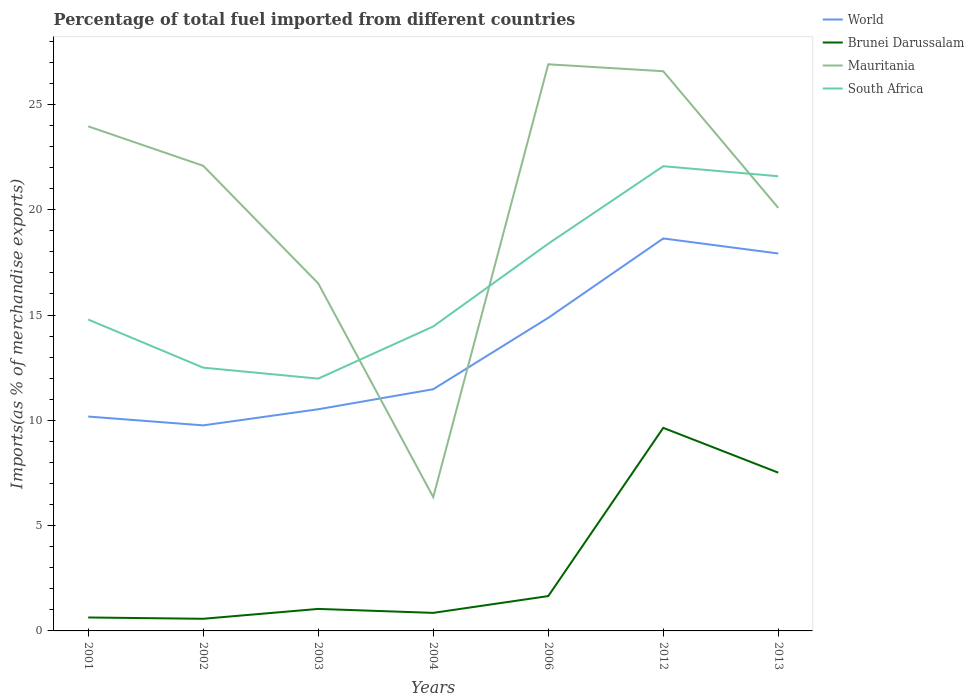Does the line corresponding to South Africa intersect with the line corresponding to Brunei Darussalam?
Your response must be concise. No. Is the number of lines equal to the number of legend labels?
Offer a terse response. Yes. Across all years, what is the maximum percentage of imports to different countries in South Africa?
Your answer should be very brief. 11.98. In which year was the percentage of imports to different countries in Brunei Darussalam maximum?
Offer a very short reply. 2002. What is the total percentage of imports to different countries in Brunei Darussalam in the graph?
Offer a terse response. -7.99. What is the difference between the highest and the second highest percentage of imports to different countries in World?
Give a very brief answer. 8.88. What is the difference between the highest and the lowest percentage of imports to different countries in Brunei Darussalam?
Provide a short and direct response. 2. Is the percentage of imports to different countries in World strictly greater than the percentage of imports to different countries in South Africa over the years?
Your answer should be compact. Yes. What is the difference between two consecutive major ticks on the Y-axis?
Keep it short and to the point. 5. Are the values on the major ticks of Y-axis written in scientific E-notation?
Provide a succinct answer. No. Does the graph contain any zero values?
Your response must be concise. No. Does the graph contain grids?
Provide a short and direct response. No. Where does the legend appear in the graph?
Make the answer very short. Top right. How are the legend labels stacked?
Offer a very short reply. Vertical. What is the title of the graph?
Make the answer very short. Percentage of total fuel imported from different countries. What is the label or title of the Y-axis?
Your answer should be compact. Imports(as % of merchandise exports). What is the Imports(as % of merchandise exports) of World in 2001?
Offer a very short reply. 10.18. What is the Imports(as % of merchandise exports) of Brunei Darussalam in 2001?
Your answer should be compact. 0.64. What is the Imports(as % of merchandise exports) of Mauritania in 2001?
Provide a short and direct response. 23.96. What is the Imports(as % of merchandise exports) in South Africa in 2001?
Your answer should be very brief. 14.79. What is the Imports(as % of merchandise exports) of World in 2002?
Your answer should be very brief. 9.76. What is the Imports(as % of merchandise exports) in Brunei Darussalam in 2002?
Make the answer very short. 0.58. What is the Imports(as % of merchandise exports) in Mauritania in 2002?
Your answer should be compact. 22.09. What is the Imports(as % of merchandise exports) in South Africa in 2002?
Your answer should be compact. 12.5. What is the Imports(as % of merchandise exports) in World in 2003?
Give a very brief answer. 10.53. What is the Imports(as % of merchandise exports) of Brunei Darussalam in 2003?
Your answer should be compact. 1.05. What is the Imports(as % of merchandise exports) in Mauritania in 2003?
Offer a terse response. 16.5. What is the Imports(as % of merchandise exports) in South Africa in 2003?
Give a very brief answer. 11.98. What is the Imports(as % of merchandise exports) of World in 2004?
Keep it short and to the point. 11.48. What is the Imports(as % of merchandise exports) in Brunei Darussalam in 2004?
Make the answer very short. 0.86. What is the Imports(as % of merchandise exports) of Mauritania in 2004?
Your answer should be very brief. 6.35. What is the Imports(as % of merchandise exports) in South Africa in 2004?
Offer a very short reply. 14.46. What is the Imports(as % of merchandise exports) of World in 2006?
Offer a terse response. 14.87. What is the Imports(as % of merchandise exports) in Brunei Darussalam in 2006?
Offer a terse response. 1.65. What is the Imports(as % of merchandise exports) in Mauritania in 2006?
Your response must be concise. 26.91. What is the Imports(as % of merchandise exports) in South Africa in 2006?
Your answer should be compact. 18.39. What is the Imports(as % of merchandise exports) in World in 2012?
Give a very brief answer. 18.64. What is the Imports(as % of merchandise exports) in Brunei Darussalam in 2012?
Ensure brevity in your answer.  9.64. What is the Imports(as % of merchandise exports) of Mauritania in 2012?
Make the answer very short. 26.58. What is the Imports(as % of merchandise exports) in South Africa in 2012?
Offer a very short reply. 22.07. What is the Imports(as % of merchandise exports) in World in 2013?
Your answer should be compact. 17.92. What is the Imports(as % of merchandise exports) in Brunei Darussalam in 2013?
Your answer should be compact. 7.52. What is the Imports(as % of merchandise exports) in Mauritania in 2013?
Offer a terse response. 20.09. What is the Imports(as % of merchandise exports) of South Africa in 2013?
Your response must be concise. 21.59. Across all years, what is the maximum Imports(as % of merchandise exports) in World?
Provide a succinct answer. 18.64. Across all years, what is the maximum Imports(as % of merchandise exports) in Brunei Darussalam?
Ensure brevity in your answer.  9.64. Across all years, what is the maximum Imports(as % of merchandise exports) of Mauritania?
Your answer should be compact. 26.91. Across all years, what is the maximum Imports(as % of merchandise exports) of South Africa?
Your answer should be compact. 22.07. Across all years, what is the minimum Imports(as % of merchandise exports) of World?
Your answer should be very brief. 9.76. Across all years, what is the minimum Imports(as % of merchandise exports) of Brunei Darussalam?
Offer a terse response. 0.58. Across all years, what is the minimum Imports(as % of merchandise exports) in Mauritania?
Ensure brevity in your answer.  6.35. Across all years, what is the minimum Imports(as % of merchandise exports) in South Africa?
Offer a terse response. 11.98. What is the total Imports(as % of merchandise exports) of World in the graph?
Give a very brief answer. 93.37. What is the total Imports(as % of merchandise exports) of Brunei Darussalam in the graph?
Ensure brevity in your answer.  21.93. What is the total Imports(as % of merchandise exports) in Mauritania in the graph?
Provide a succinct answer. 142.47. What is the total Imports(as % of merchandise exports) of South Africa in the graph?
Offer a terse response. 115.77. What is the difference between the Imports(as % of merchandise exports) of World in 2001 and that in 2002?
Ensure brevity in your answer.  0.42. What is the difference between the Imports(as % of merchandise exports) of Brunei Darussalam in 2001 and that in 2002?
Your answer should be very brief. 0.06. What is the difference between the Imports(as % of merchandise exports) of Mauritania in 2001 and that in 2002?
Your response must be concise. 1.87. What is the difference between the Imports(as % of merchandise exports) of South Africa in 2001 and that in 2002?
Provide a short and direct response. 2.29. What is the difference between the Imports(as % of merchandise exports) in World in 2001 and that in 2003?
Provide a succinct answer. -0.35. What is the difference between the Imports(as % of merchandise exports) in Brunei Darussalam in 2001 and that in 2003?
Your answer should be compact. -0.41. What is the difference between the Imports(as % of merchandise exports) in Mauritania in 2001 and that in 2003?
Your answer should be very brief. 7.46. What is the difference between the Imports(as % of merchandise exports) in South Africa in 2001 and that in 2003?
Your answer should be very brief. 2.81. What is the difference between the Imports(as % of merchandise exports) of World in 2001 and that in 2004?
Provide a succinct answer. -1.3. What is the difference between the Imports(as % of merchandise exports) of Brunei Darussalam in 2001 and that in 2004?
Keep it short and to the point. -0.22. What is the difference between the Imports(as % of merchandise exports) of Mauritania in 2001 and that in 2004?
Your answer should be compact. 17.61. What is the difference between the Imports(as % of merchandise exports) of South Africa in 2001 and that in 2004?
Your response must be concise. 0.33. What is the difference between the Imports(as % of merchandise exports) of World in 2001 and that in 2006?
Provide a succinct answer. -4.69. What is the difference between the Imports(as % of merchandise exports) of Brunei Darussalam in 2001 and that in 2006?
Provide a short and direct response. -1.02. What is the difference between the Imports(as % of merchandise exports) in Mauritania in 2001 and that in 2006?
Your response must be concise. -2.95. What is the difference between the Imports(as % of merchandise exports) of South Africa in 2001 and that in 2006?
Provide a short and direct response. -3.6. What is the difference between the Imports(as % of merchandise exports) of World in 2001 and that in 2012?
Make the answer very short. -8.46. What is the difference between the Imports(as % of merchandise exports) in Brunei Darussalam in 2001 and that in 2012?
Keep it short and to the point. -9. What is the difference between the Imports(as % of merchandise exports) in Mauritania in 2001 and that in 2012?
Your answer should be very brief. -2.62. What is the difference between the Imports(as % of merchandise exports) of South Africa in 2001 and that in 2012?
Give a very brief answer. -7.28. What is the difference between the Imports(as % of merchandise exports) in World in 2001 and that in 2013?
Ensure brevity in your answer.  -7.74. What is the difference between the Imports(as % of merchandise exports) in Brunei Darussalam in 2001 and that in 2013?
Provide a short and direct response. -6.88. What is the difference between the Imports(as % of merchandise exports) of Mauritania in 2001 and that in 2013?
Provide a succinct answer. 3.87. What is the difference between the Imports(as % of merchandise exports) of South Africa in 2001 and that in 2013?
Keep it short and to the point. -6.8. What is the difference between the Imports(as % of merchandise exports) in World in 2002 and that in 2003?
Make the answer very short. -0.77. What is the difference between the Imports(as % of merchandise exports) in Brunei Darussalam in 2002 and that in 2003?
Keep it short and to the point. -0.47. What is the difference between the Imports(as % of merchandise exports) in Mauritania in 2002 and that in 2003?
Your answer should be very brief. 5.59. What is the difference between the Imports(as % of merchandise exports) of South Africa in 2002 and that in 2003?
Offer a terse response. 0.52. What is the difference between the Imports(as % of merchandise exports) of World in 2002 and that in 2004?
Your answer should be very brief. -1.72. What is the difference between the Imports(as % of merchandise exports) in Brunei Darussalam in 2002 and that in 2004?
Provide a succinct answer. -0.28. What is the difference between the Imports(as % of merchandise exports) of Mauritania in 2002 and that in 2004?
Offer a very short reply. 15.73. What is the difference between the Imports(as % of merchandise exports) of South Africa in 2002 and that in 2004?
Make the answer very short. -1.96. What is the difference between the Imports(as % of merchandise exports) of World in 2002 and that in 2006?
Provide a short and direct response. -5.11. What is the difference between the Imports(as % of merchandise exports) in Brunei Darussalam in 2002 and that in 2006?
Offer a terse response. -1.08. What is the difference between the Imports(as % of merchandise exports) in Mauritania in 2002 and that in 2006?
Ensure brevity in your answer.  -4.82. What is the difference between the Imports(as % of merchandise exports) of South Africa in 2002 and that in 2006?
Keep it short and to the point. -5.89. What is the difference between the Imports(as % of merchandise exports) in World in 2002 and that in 2012?
Offer a very short reply. -8.88. What is the difference between the Imports(as % of merchandise exports) of Brunei Darussalam in 2002 and that in 2012?
Offer a very short reply. -9.07. What is the difference between the Imports(as % of merchandise exports) of Mauritania in 2002 and that in 2012?
Ensure brevity in your answer.  -4.49. What is the difference between the Imports(as % of merchandise exports) in South Africa in 2002 and that in 2012?
Keep it short and to the point. -9.57. What is the difference between the Imports(as % of merchandise exports) of World in 2002 and that in 2013?
Give a very brief answer. -8.16. What is the difference between the Imports(as % of merchandise exports) of Brunei Darussalam in 2002 and that in 2013?
Offer a terse response. -6.94. What is the difference between the Imports(as % of merchandise exports) of Mauritania in 2002 and that in 2013?
Provide a succinct answer. 2. What is the difference between the Imports(as % of merchandise exports) of South Africa in 2002 and that in 2013?
Your response must be concise. -9.09. What is the difference between the Imports(as % of merchandise exports) in World in 2003 and that in 2004?
Your answer should be compact. -0.95. What is the difference between the Imports(as % of merchandise exports) in Brunei Darussalam in 2003 and that in 2004?
Your response must be concise. 0.19. What is the difference between the Imports(as % of merchandise exports) in Mauritania in 2003 and that in 2004?
Offer a very short reply. 10.15. What is the difference between the Imports(as % of merchandise exports) in South Africa in 2003 and that in 2004?
Make the answer very short. -2.48. What is the difference between the Imports(as % of merchandise exports) in World in 2003 and that in 2006?
Offer a very short reply. -4.34. What is the difference between the Imports(as % of merchandise exports) in Brunei Darussalam in 2003 and that in 2006?
Provide a succinct answer. -0.61. What is the difference between the Imports(as % of merchandise exports) of Mauritania in 2003 and that in 2006?
Give a very brief answer. -10.41. What is the difference between the Imports(as % of merchandise exports) of South Africa in 2003 and that in 2006?
Your answer should be compact. -6.41. What is the difference between the Imports(as % of merchandise exports) of World in 2003 and that in 2012?
Provide a short and direct response. -8.11. What is the difference between the Imports(as % of merchandise exports) in Brunei Darussalam in 2003 and that in 2012?
Provide a short and direct response. -8.6. What is the difference between the Imports(as % of merchandise exports) in Mauritania in 2003 and that in 2012?
Provide a short and direct response. -10.08. What is the difference between the Imports(as % of merchandise exports) of South Africa in 2003 and that in 2012?
Provide a short and direct response. -10.09. What is the difference between the Imports(as % of merchandise exports) of World in 2003 and that in 2013?
Ensure brevity in your answer.  -7.4. What is the difference between the Imports(as % of merchandise exports) in Brunei Darussalam in 2003 and that in 2013?
Provide a succinct answer. -6.47. What is the difference between the Imports(as % of merchandise exports) of Mauritania in 2003 and that in 2013?
Your response must be concise. -3.59. What is the difference between the Imports(as % of merchandise exports) of South Africa in 2003 and that in 2013?
Make the answer very short. -9.61. What is the difference between the Imports(as % of merchandise exports) in World in 2004 and that in 2006?
Offer a very short reply. -3.39. What is the difference between the Imports(as % of merchandise exports) in Brunei Darussalam in 2004 and that in 2006?
Your answer should be very brief. -0.8. What is the difference between the Imports(as % of merchandise exports) in Mauritania in 2004 and that in 2006?
Provide a short and direct response. -20.55. What is the difference between the Imports(as % of merchandise exports) in South Africa in 2004 and that in 2006?
Provide a succinct answer. -3.93. What is the difference between the Imports(as % of merchandise exports) in World in 2004 and that in 2012?
Make the answer very short. -7.16. What is the difference between the Imports(as % of merchandise exports) of Brunei Darussalam in 2004 and that in 2012?
Your response must be concise. -8.79. What is the difference between the Imports(as % of merchandise exports) of Mauritania in 2004 and that in 2012?
Your answer should be compact. -20.22. What is the difference between the Imports(as % of merchandise exports) of South Africa in 2004 and that in 2012?
Provide a short and direct response. -7.61. What is the difference between the Imports(as % of merchandise exports) in World in 2004 and that in 2013?
Your answer should be compact. -6.44. What is the difference between the Imports(as % of merchandise exports) in Brunei Darussalam in 2004 and that in 2013?
Provide a short and direct response. -6.66. What is the difference between the Imports(as % of merchandise exports) of Mauritania in 2004 and that in 2013?
Provide a short and direct response. -13.73. What is the difference between the Imports(as % of merchandise exports) in South Africa in 2004 and that in 2013?
Your answer should be very brief. -7.13. What is the difference between the Imports(as % of merchandise exports) of World in 2006 and that in 2012?
Your response must be concise. -3.77. What is the difference between the Imports(as % of merchandise exports) in Brunei Darussalam in 2006 and that in 2012?
Make the answer very short. -7.99. What is the difference between the Imports(as % of merchandise exports) in Mauritania in 2006 and that in 2012?
Ensure brevity in your answer.  0.33. What is the difference between the Imports(as % of merchandise exports) in South Africa in 2006 and that in 2012?
Your answer should be compact. -3.68. What is the difference between the Imports(as % of merchandise exports) of World in 2006 and that in 2013?
Provide a succinct answer. -3.05. What is the difference between the Imports(as % of merchandise exports) in Brunei Darussalam in 2006 and that in 2013?
Your response must be concise. -5.86. What is the difference between the Imports(as % of merchandise exports) of Mauritania in 2006 and that in 2013?
Make the answer very short. 6.82. What is the difference between the Imports(as % of merchandise exports) in South Africa in 2006 and that in 2013?
Keep it short and to the point. -3.2. What is the difference between the Imports(as % of merchandise exports) in World in 2012 and that in 2013?
Offer a very short reply. 0.71. What is the difference between the Imports(as % of merchandise exports) of Brunei Darussalam in 2012 and that in 2013?
Keep it short and to the point. 2.13. What is the difference between the Imports(as % of merchandise exports) of Mauritania in 2012 and that in 2013?
Ensure brevity in your answer.  6.49. What is the difference between the Imports(as % of merchandise exports) in South Africa in 2012 and that in 2013?
Your answer should be compact. 0.48. What is the difference between the Imports(as % of merchandise exports) in World in 2001 and the Imports(as % of merchandise exports) in Brunei Darussalam in 2002?
Keep it short and to the point. 9.6. What is the difference between the Imports(as % of merchandise exports) of World in 2001 and the Imports(as % of merchandise exports) of Mauritania in 2002?
Your answer should be compact. -11.91. What is the difference between the Imports(as % of merchandise exports) of World in 2001 and the Imports(as % of merchandise exports) of South Africa in 2002?
Your answer should be compact. -2.32. What is the difference between the Imports(as % of merchandise exports) of Brunei Darussalam in 2001 and the Imports(as % of merchandise exports) of Mauritania in 2002?
Make the answer very short. -21.45. What is the difference between the Imports(as % of merchandise exports) of Brunei Darussalam in 2001 and the Imports(as % of merchandise exports) of South Africa in 2002?
Your response must be concise. -11.86. What is the difference between the Imports(as % of merchandise exports) of Mauritania in 2001 and the Imports(as % of merchandise exports) of South Africa in 2002?
Your response must be concise. 11.46. What is the difference between the Imports(as % of merchandise exports) in World in 2001 and the Imports(as % of merchandise exports) in Brunei Darussalam in 2003?
Provide a short and direct response. 9.13. What is the difference between the Imports(as % of merchandise exports) in World in 2001 and the Imports(as % of merchandise exports) in Mauritania in 2003?
Make the answer very short. -6.32. What is the difference between the Imports(as % of merchandise exports) of World in 2001 and the Imports(as % of merchandise exports) of South Africa in 2003?
Offer a very short reply. -1.8. What is the difference between the Imports(as % of merchandise exports) of Brunei Darussalam in 2001 and the Imports(as % of merchandise exports) of Mauritania in 2003?
Ensure brevity in your answer.  -15.86. What is the difference between the Imports(as % of merchandise exports) of Brunei Darussalam in 2001 and the Imports(as % of merchandise exports) of South Africa in 2003?
Offer a very short reply. -11.34. What is the difference between the Imports(as % of merchandise exports) of Mauritania in 2001 and the Imports(as % of merchandise exports) of South Africa in 2003?
Offer a terse response. 11.98. What is the difference between the Imports(as % of merchandise exports) of World in 2001 and the Imports(as % of merchandise exports) of Brunei Darussalam in 2004?
Offer a terse response. 9.32. What is the difference between the Imports(as % of merchandise exports) of World in 2001 and the Imports(as % of merchandise exports) of Mauritania in 2004?
Offer a terse response. 3.83. What is the difference between the Imports(as % of merchandise exports) of World in 2001 and the Imports(as % of merchandise exports) of South Africa in 2004?
Your answer should be compact. -4.28. What is the difference between the Imports(as % of merchandise exports) in Brunei Darussalam in 2001 and the Imports(as % of merchandise exports) in Mauritania in 2004?
Your answer should be compact. -5.72. What is the difference between the Imports(as % of merchandise exports) of Brunei Darussalam in 2001 and the Imports(as % of merchandise exports) of South Africa in 2004?
Ensure brevity in your answer.  -13.82. What is the difference between the Imports(as % of merchandise exports) in Mauritania in 2001 and the Imports(as % of merchandise exports) in South Africa in 2004?
Give a very brief answer. 9.5. What is the difference between the Imports(as % of merchandise exports) of World in 2001 and the Imports(as % of merchandise exports) of Brunei Darussalam in 2006?
Give a very brief answer. 8.53. What is the difference between the Imports(as % of merchandise exports) of World in 2001 and the Imports(as % of merchandise exports) of Mauritania in 2006?
Ensure brevity in your answer.  -16.73. What is the difference between the Imports(as % of merchandise exports) in World in 2001 and the Imports(as % of merchandise exports) in South Africa in 2006?
Your answer should be compact. -8.21. What is the difference between the Imports(as % of merchandise exports) in Brunei Darussalam in 2001 and the Imports(as % of merchandise exports) in Mauritania in 2006?
Offer a terse response. -26.27. What is the difference between the Imports(as % of merchandise exports) in Brunei Darussalam in 2001 and the Imports(as % of merchandise exports) in South Africa in 2006?
Make the answer very short. -17.75. What is the difference between the Imports(as % of merchandise exports) of Mauritania in 2001 and the Imports(as % of merchandise exports) of South Africa in 2006?
Provide a succinct answer. 5.57. What is the difference between the Imports(as % of merchandise exports) in World in 2001 and the Imports(as % of merchandise exports) in Brunei Darussalam in 2012?
Provide a short and direct response. 0.54. What is the difference between the Imports(as % of merchandise exports) in World in 2001 and the Imports(as % of merchandise exports) in Mauritania in 2012?
Provide a short and direct response. -16.4. What is the difference between the Imports(as % of merchandise exports) of World in 2001 and the Imports(as % of merchandise exports) of South Africa in 2012?
Offer a very short reply. -11.89. What is the difference between the Imports(as % of merchandise exports) in Brunei Darussalam in 2001 and the Imports(as % of merchandise exports) in Mauritania in 2012?
Offer a very short reply. -25.94. What is the difference between the Imports(as % of merchandise exports) of Brunei Darussalam in 2001 and the Imports(as % of merchandise exports) of South Africa in 2012?
Ensure brevity in your answer.  -21.43. What is the difference between the Imports(as % of merchandise exports) of Mauritania in 2001 and the Imports(as % of merchandise exports) of South Africa in 2012?
Keep it short and to the point. 1.89. What is the difference between the Imports(as % of merchandise exports) in World in 2001 and the Imports(as % of merchandise exports) in Brunei Darussalam in 2013?
Offer a very short reply. 2.66. What is the difference between the Imports(as % of merchandise exports) of World in 2001 and the Imports(as % of merchandise exports) of Mauritania in 2013?
Offer a terse response. -9.91. What is the difference between the Imports(as % of merchandise exports) in World in 2001 and the Imports(as % of merchandise exports) in South Africa in 2013?
Offer a very short reply. -11.41. What is the difference between the Imports(as % of merchandise exports) of Brunei Darussalam in 2001 and the Imports(as % of merchandise exports) of Mauritania in 2013?
Make the answer very short. -19.45. What is the difference between the Imports(as % of merchandise exports) of Brunei Darussalam in 2001 and the Imports(as % of merchandise exports) of South Africa in 2013?
Your answer should be very brief. -20.95. What is the difference between the Imports(as % of merchandise exports) in Mauritania in 2001 and the Imports(as % of merchandise exports) in South Africa in 2013?
Provide a short and direct response. 2.37. What is the difference between the Imports(as % of merchandise exports) of World in 2002 and the Imports(as % of merchandise exports) of Brunei Darussalam in 2003?
Your response must be concise. 8.72. What is the difference between the Imports(as % of merchandise exports) in World in 2002 and the Imports(as % of merchandise exports) in Mauritania in 2003?
Your answer should be very brief. -6.74. What is the difference between the Imports(as % of merchandise exports) of World in 2002 and the Imports(as % of merchandise exports) of South Africa in 2003?
Your response must be concise. -2.22. What is the difference between the Imports(as % of merchandise exports) in Brunei Darussalam in 2002 and the Imports(as % of merchandise exports) in Mauritania in 2003?
Your answer should be compact. -15.92. What is the difference between the Imports(as % of merchandise exports) in Brunei Darussalam in 2002 and the Imports(as % of merchandise exports) in South Africa in 2003?
Your answer should be compact. -11.4. What is the difference between the Imports(as % of merchandise exports) in Mauritania in 2002 and the Imports(as % of merchandise exports) in South Africa in 2003?
Provide a succinct answer. 10.11. What is the difference between the Imports(as % of merchandise exports) of World in 2002 and the Imports(as % of merchandise exports) of Brunei Darussalam in 2004?
Your answer should be very brief. 8.9. What is the difference between the Imports(as % of merchandise exports) in World in 2002 and the Imports(as % of merchandise exports) in Mauritania in 2004?
Ensure brevity in your answer.  3.41. What is the difference between the Imports(as % of merchandise exports) in World in 2002 and the Imports(as % of merchandise exports) in South Africa in 2004?
Ensure brevity in your answer.  -4.7. What is the difference between the Imports(as % of merchandise exports) of Brunei Darussalam in 2002 and the Imports(as % of merchandise exports) of Mauritania in 2004?
Offer a very short reply. -5.78. What is the difference between the Imports(as % of merchandise exports) in Brunei Darussalam in 2002 and the Imports(as % of merchandise exports) in South Africa in 2004?
Provide a short and direct response. -13.88. What is the difference between the Imports(as % of merchandise exports) in Mauritania in 2002 and the Imports(as % of merchandise exports) in South Africa in 2004?
Your answer should be very brief. 7.63. What is the difference between the Imports(as % of merchandise exports) of World in 2002 and the Imports(as % of merchandise exports) of Brunei Darussalam in 2006?
Provide a short and direct response. 8.11. What is the difference between the Imports(as % of merchandise exports) in World in 2002 and the Imports(as % of merchandise exports) in Mauritania in 2006?
Provide a short and direct response. -17.15. What is the difference between the Imports(as % of merchandise exports) in World in 2002 and the Imports(as % of merchandise exports) in South Africa in 2006?
Keep it short and to the point. -8.63. What is the difference between the Imports(as % of merchandise exports) of Brunei Darussalam in 2002 and the Imports(as % of merchandise exports) of Mauritania in 2006?
Offer a terse response. -26.33. What is the difference between the Imports(as % of merchandise exports) in Brunei Darussalam in 2002 and the Imports(as % of merchandise exports) in South Africa in 2006?
Provide a succinct answer. -17.81. What is the difference between the Imports(as % of merchandise exports) in Mauritania in 2002 and the Imports(as % of merchandise exports) in South Africa in 2006?
Offer a very short reply. 3.7. What is the difference between the Imports(as % of merchandise exports) in World in 2002 and the Imports(as % of merchandise exports) in Brunei Darussalam in 2012?
Offer a very short reply. 0.12. What is the difference between the Imports(as % of merchandise exports) in World in 2002 and the Imports(as % of merchandise exports) in Mauritania in 2012?
Provide a succinct answer. -16.82. What is the difference between the Imports(as % of merchandise exports) of World in 2002 and the Imports(as % of merchandise exports) of South Africa in 2012?
Offer a terse response. -12.31. What is the difference between the Imports(as % of merchandise exports) in Brunei Darussalam in 2002 and the Imports(as % of merchandise exports) in Mauritania in 2012?
Offer a very short reply. -26. What is the difference between the Imports(as % of merchandise exports) of Brunei Darussalam in 2002 and the Imports(as % of merchandise exports) of South Africa in 2012?
Your answer should be compact. -21.49. What is the difference between the Imports(as % of merchandise exports) in Mauritania in 2002 and the Imports(as % of merchandise exports) in South Africa in 2012?
Provide a succinct answer. 0.02. What is the difference between the Imports(as % of merchandise exports) of World in 2002 and the Imports(as % of merchandise exports) of Brunei Darussalam in 2013?
Your answer should be compact. 2.25. What is the difference between the Imports(as % of merchandise exports) of World in 2002 and the Imports(as % of merchandise exports) of Mauritania in 2013?
Make the answer very short. -10.33. What is the difference between the Imports(as % of merchandise exports) in World in 2002 and the Imports(as % of merchandise exports) in South Africa in 2013?
Make the answer very short. -11.83. What is the difference between the Imports(as % of merchandise exports) in Brunei Darussalam in 2002 and the Imports(as % of merchandise exports) in Mauritania in 2013?
Make the answer very short. -19.51. What is the difference between the Imports(as % of merchandise exports) of Brunei Darussalam in 2002 and the Imports(as % of merchandise exports) of South Africa in 2013?
Provide a short and direct response. -21.01. What is the difference between the Imports(as % of merchandise exports) in Mauritania in 2002 and the Imports(as % of merchandise exports) in South Africa in 2013?
Keep it short and to the point. 0.5. What is the difference between the Imports(as % of merchandise exports) of World in 2003 and the Imports(as % of merchandise exports) of Brunei Darussalam in 2004?
Your answer should be compact. 9.67. What is the difference between the Imports(as % of merchandise exports) in World in 2003 and the Imports(as % of merchandise exports) in Mauritania in 2004?
Your answer should be compact. 4.17. What is the difference between the Imports(as % of merchandise exports) of World in 2003 and the Imports(as % of merchandise exports) of South Africa in 2004?
Keep it short and to the point. -3.93. What is the difference between the Imports(as % of merchandise exports) in Brunei Darussalam in 2003 and the Imports(as % of merchandise exports) in Mauritania in 2004?
Your response must be concise. -5.31. What is the difference between the Imports(as % of merchandise exports) in Brunei Darussalam in 2003 and the Imports(as % of merchandise exports) in South Africa in 2004?
Ensure brevity in your answer.  -13.41. What is the difference between the Imports(as % of merchandise exports) of Mauritania in 2003 and the Imports(as % of merchandise exports) of South Africa in 2004?
Offer a terse response. 2.04. What is the difference between the Imports(as % of merchandise exports) of World in 2003 and the Imports(as % of merchandise exports) of Brunei Darussalam in 2006?
Offer a terse response. 8.87. What is the difference between the Imports(as % of merchandise exports) in World in 2003 and the Imports(as % of merchandise exports) in Mauritania in 2006?
Make the answer very short. -16.38. What is the difference between the Imports(as % of merchandise exports) in World in 2003 and the Imports(as % of merchandise exports) in South Africa in 2006?
Provide a short and direct response. -7.86. What is the difference between the Imports(as % of merchandise exports) of Brunei Darussalam in 2003 and the Imports(as % of merchandise exports) of Mauritania in 2006?
Give a very brief answer. -25.86. What is the difference between the Imports(as % of merchandise exports) in Brunei Darussalam in 2003 and the Imports(as % of merchandise exports) in South Africa in 2006?
Give a very brief answer. -17.34. What is the difference between the Imports(as % of merchandise exports) of Mauritania in 2003 and the Imports(as % of merchandise exports) of South Africa in 2006?
Your response must be concise. -1.89. What is the difference between the Imports(as % of merchandise exports) of World in 2003 and the Imports(as % of merchandise exports) of Brunei Darussalam in 2012?
Provide a succinct answer. 0.88. What is the difference between the Imports(as % of merchandise exports) in World in 2003 and the Imports(as % of merchandise exports) in Mauritania in 2012?
Offer a terse response. -16.05. What is the difference between the Imports(as % of merchandise exports) of World in 2003 and the Imports(as % of merchandise exports) of South Africa in 2012?
Provide a short and direct response. -11.54. What is the difference between the Imports(as % of merchandise exports) of Brunei Darussalam in 2003 and the Imports(as % of merchandise exports) of Mauritania in 2012?
Your response must be concise. -25.53. What is the difference between the Imports(as % of merchandise exports) in Brunei Darussalam in 2003 and the Imports(as % of merchandise exports) in South Africa in 2012?
Keep it short and to the point. -21.02. What is the difference between the Imports(as % of merchandise exports) of Mauritania in 2003 and the Imports(as % of merchandise exports) of South Africa in 2012?
Offer a very short reply. -5.57. What is the difference between the Imports(as % of merchandise exports) of World in 2003 and the Imports(as % of merchandise exports) of Brunei Darussalam in 2013?
Offer a very short reply. 3.01. What is the difference between the Imports(as % of merchandise exports) of World in 2003 and the Imports(as % of merchandise exports) of Mauritania in 2013?
Provide a short and direct response. -9.56. What is the difference between the Imports(as % of merchandise exports) of World in 2003 and the Imports(as % of merchandise exports) of South Africa in 2013?
Give a very brief answer. -11.06. What is the difference between the Imports(as % of merchandise exports) in Brunei Darussalam in 2003 and the Imports(as % of merchandise exports) in Mauritania in 2013?
Keep it short and to the point. -19.04. What is the difference between the Imports(as % of merchandise exports) in Brunei Darussalam in 2003 and the Imports(as % of merchandise exports) in South Africa in 2013?
Your answer should be compact. -20.55. What is the difference between the Imports(as % of merchandise exports) of Mauritania in 2003 and the Imports(as % of merchandise exports) of South Africa in 2013?
Provide a short and direct response. -5.09. What is the difference between the Imports(as % of merchandise exports) in World in 2004 and the Imports(as % of merchandise exports) in Brunei Darussalam in 2006?
Make the answer very short. 9.82. What is the difference between the Imports(as % of merchandise exports) of World in 2004 and the Imports(as % of merchandise exports) of Mauritania in 2006?
Give a very brief answer. -15.43. What is the difference between the Imports(as % of merchandise exports) in World in 2004 and the Imports(as % of merchandise exports) in South Africa in 2006?
Make the answer very short. -6.91. What is the difference between the Imports(as % of merchandise exports) of Brunei Darussalam in 2004 and the Imports(as % of merchandise exports) of Mauritania in 2006?
Give a very brief answer. -26.05. What is the difference between the Imports(as % of merchandise exports) of Brunei Darussalam in 2004 and the Imports(as % of merchandise exports) of South Africa in 2006?
Make the answer very short. -17.53. What is the difference between the Imports(as % of merchandise exports) of Mauritania in 2004 and the Imports(as % of merchandise exports) of South Africa in 2006?
Offer a terse response. -12.03. What is the difference between the Imports(as % of merchandise exports) in World in 2004 and the Imports(as % of merchandise exports) in Brunei Darussalam in 2012?
Your answer should be compact. 1.83. What is the difference between the Imports(as % of merchandise exports) in World in 2004 and the Imports(as % of merchandise exports) in Mauritania in 2012?
Keep it short and to the point. -15.1. What is the difference between the Imports(as % of merchandise exports) of World in 2004 and the Imports(as % of merchandise exports) of South Africa in 2012?
Ensure brevity in your answer.  -10.59. What is the difference between the Imports(as % of merchandise exports) in Brunei Darussalam in 2004 and the Imports(as % of merchandise exports) in Mauritania in 2012?
Give a very brief answer. -25.72. What is the difference between the Imports(as % of merchandise exports) of Brunei Darussalam in 2004 and the Imports(as % of merchandise exports) of South Africa in 2012?
Make the answer very short. -21.21. What is the difference between the Imports(as % of merchandise exports) of Mauritania in 2004 and the Imports(as % of merchandise exports) of South Africa in 2012?
Your answer should be compact. -15.71. What is the difference between the Imports(as % of merchandise exports) in World in 2004 and the Imports(as % of merchandise exports) in Brunei Darussalam in 2013?
Provide a succinct answer. 3.96. What is the difference between the Imports(as % of merchandise exports) of World in 2004 and the Imports(as % of merchandise exports) of Mauritania in 2013?
Your answer should be compact. -8.61. What is the difference between the Imports(as % of merchandise exports) of World in 2004 and the Imports(as % of merchandise exports) of South Africa in 2013?
Offer a very short reply. -10.11. What is the difference between the Imports(as % of merchandise exports) in Brunei Darussalam in 2004 and the Imports(as % of merchandise exports) in Mauritania in 2013?
Your answer should be compact. -19.23. What is the difference between the Imports(as % of merchandise exports) of Brunei Darussalam in 2004 and the Imports(as % of merchandise exports) of South Africa in 2013?
Give a very brief answer. -20.73. What is the difference between the Imports(as % of merchandise exports) in Mauritania in 2004 and the Imports(as % of merchandise exports) in South Africa in 2013?
Provide a short and direct response. -15.24. What is the difference between the Imports(as % of merchandise exports) of World in 2006 and the Imports(as % of merchandise exports) of Brunei Darussalam in 2012?
Your answer should be compact. 5.22. What is the difference between the Imports(as % of merchandise exports) in World in 2006 and the Imports(as % of merchandise exports) in Mauritania in 2012?
Provide a short and direct response. -11.71. What is the difference between the Imports(as % of merchandise exports) in World in 2006 and the Imports(as % of merchandise exports) in South Africa in 2012?
Provide a short and direct response. -7.2. What is the difference between the Imports(as % of merchandise exports) of Brunei Darussalam in 2006 and the Imports(as % of merchandise exports) of Mauritania in 2012?
Provide a short and direct response. -24.92. What is the difference between the Imports(as % of merchandise exports) of Brunei Darussalam in 2006 and the Imports(as % of merchandise exports) of South Africa in 2012?
Provide a short and direct response. -20.41. What is the difference between the Imports(as % of merchandise exports) of Mauritania in 2006 and the Imports(as % of merchandise exports) of South Africa in 2012?
Your answer should be compact. 4.84. What is the difference between the Imports(as % of merchandise exports) of World in 2006 and the Imports(as % of merchandise exports) of Brunei Darussalam in 2013?
Offer a very short reply. 7.35. What is the difference between the Imports(as % of merchandise exports) of World in 2006 and the Imports(as % of merchandise exports) of Mauritania in 2013?
Your answer should be compact. -5.22. What is the difference between the Imports(as % of merchandise exports) of World in 2006 and the Imports(as % of merchandise exports) of South Africa in 2013?
Ensure brevity in your answer.  -6.72. What is the difference between the Imports(as % of merchandise exports) in Brunei Darussalam in 2006 and the Imports(as % of merchandise exports) in Mauritania in 2013?
Make the answer very short. -18.43. What is the difference between the Imports(as % of merchandise exports) in Brunei Darussalam in 2006 and the Imports(as % of merchandise exports) in South Africa in 2013?
Make the answer very short. -19.94. What is the difference between the Imports(as % of merchandise exports) of Mauritania in 2006 and the Imports(as % of merchandise exports) of South Africa in 2013?
Make the answer very short. 5.32. What is the difference between the Imports(as % of merchandise exports) in World in 2012 and the Imports(as % of merchandise exports) in Brunei Darussalam in 2013?
Your response must be concise. 11.12. What is the difference between the Imports(as % of merchandise exports) of World in 2012 and the Imports(as % of merchandise exports) of Mauritania in 2013?
Make the answer very short. -1.45. What is the difference between the Imports(as % of merchandise exports) of World in 2012 and the Imports(as % of merchandise exports) of South Africa in 2013?
Keep it short and to the point. -2.95. What is the difference between the Imports(as % of merchandise exports) of Brunei Darussalam in 2012 and the Imports(as % of merchandise exports) of Mauritania in 2013?
Provide a short and direct response. -10.45. What is the difference between the Imports(as % of merchandise exports) of Brunei Darussalam in 2012 and the Imports(as % of merchandise exports) of South Africa in 2013?
Keep it short and to the point. -11.95. What is the difference between the Imports(as % of merchandise exports) in Mauritania in 2012 and the Imports(as % of merchandise exports) in South Africa in 2013?
Your answer should be compact. 4.99. What is the average Imports(as % of merchandise exports) of World per year?
Give a very brief answer. 13.34. What is the average Imports(as % of merchandise exports) of Brunei Darussalam per year?
Give a very brief answer. 3.13. What is the average Imports(as % of merchandise exports) of Mauritania per year?
Your response must be concise. 20.35. What is the average Imports(as % of merchandise exports) in South Africa per year?
Make the answer very short. 16.54. In the year 2001, what is the difference between the Imports(as % of merchandise exports) in World and Imports(as % of merchandise exports) in Brunei Darussalam?
Your answer should be compact. 9.54. In the year 2001, what is the difference between the Imports(as % of merchandise exports) of World and Imports(as % of merchandise exports) of Mauritania?
Provide a succinct answer. -13.78. In the year 2001, what is the difference between the Imports(as % of merchandise exports) of World and Imports(as % of merchandise exports) of South Africa?
Ensure brevity in your answer.  -4.61. In the year 2001, what is the difference between the Imports(as % of merchandise exports) in Brunei Darussalam and Imports(as % of merchandise exports) in Mauritania?
Offer a very short reply. -23.32. In the year 2001, what is the difference between the Imports(as % of merchandise exports) in Brunei Darussalam and Imports(as % of merchandise exports) in South Africa?
Provide a succinct answer. -14.15. In the year 2001, what is the difference between the Imports(as % of merchandise exports) in Mauritania and Imports(as % of merchandise exports) in South Africa?
Provide a short and direct response. 9.17. In the year 2002, what is the difference between the Imports(as % of merchandise exports) of World and Imports(as % of merchandise exports) of Brunei Darussalam?
Keep it short and to the point. 9.18. In the year 2002, what is the difference between the Imports(as % of merchandise exports) of World and Imports(as % of merchandise exports) of Mauritania?
Offer a terse response. -12.33. In the year 2002, what is the difference between the Imports(as % of merchandise exports) in World and Imports(as % of merchandise exports) in South Africa?
Provide a succinct answer. -2.74. In the year 2002, what is the difference between the Imports(as % of merchandise exports) in Brunei Darussalam and Imports(as % of merchandise exports) in Mauritania?
Offer a terse response. -21.51. In the year 2002, what is the difference between the Imports(as % of merchandise exports) of Brunei Darussalam and Imports(as % of merchandise exports) of South Africa?
Your response must be concise. -11.92. In the year 2002, what is the difference between the Imports(as % of merchandise exports) of Mauritania and Imports(as % of merchandise exports) of South Africa?
Offer a very short reply. 9.59. In the year 2003, what is the difference between the Imports(as % of merchandise exports) in World and Imports(as % of merchandise exports) in Brunei Darussalam?
Offer a very short reply. 9.48. In the year 2003, what is the difference between the Imports(as % of merchandise exports) of World and Imports(as % of merchandise exports) of Mauritania?
Offer a very short reply. -5.98. In the year 2003, what is the difference between the Imports(as % of merchandise exports) of World and Imports(as % of merchandise exports) of South Africa?
Keep it short and to the point. -1.46. In the year 2003, what is the difference between the Imports(as % of merchandise exports) in Brunei Darussalam and Imports(as % of merchandise exports) in Mauritania?
Your answer should be compact. -15.46. In the year 2003, what is the difference between the Imports(as % of merchandise exports) of Brunei Darussalam and Imports(as % of merchandise exports) of South Africa?
Provide a short and direct response. -10.94. In the year 2003, what is the difference between the Imports(as % of merchandise exports) in Mauritania and Imports(as % of merchandise exports) in South Africa?
Keep it short and to the point. 4.52. In the year 2004, what is the difference between the Imports(as % of merchandise exports) in World and Imports(as % of merchandise exports) in Brunei Darussalam?
Your answer should be compact. 10.62. In the year 2004, what is the difference between the Imports(as % of merchandise exports) of World and Imports(as % of merchandise exports) of Mauritania?
Provide a short and direct response. 5.12. In the year 2004, what is the difference between the Imports(as % of merchandise exports) of World and Imports(as % of merchandise exports) of South Africa?
Offer a very short reply. -2.98. In the year 2004, what is the difference between the Imports(as % of merchandise exports) of Brunei Darussalam and Imports(as % of merchandise exports) of Mauritania?
Provide a succinct answer. -5.5. In the year 2004, what is the difference between the Imports(as % of merchandise exports) of Brunei Darussalam and Imports(as % of merchandise exports) of South Africa?
Your response must be concise. -13.6. In the year 2004, what is the difference between the Imports(as % of merchandise exports) of Mauritania and Imports(as % of merchandise exports) of South Africa?
Provide a succinct answer. -8.1. In the year 2006, what is the difference between the Imports(as % of merchandise exports) in World and Imports(as % of merchandise exports) in Brunei Darussalam?
Your answer should be very brief. 13.21. In the year 2006, what is the difference between the Imports(as % of merchandise exports) of World and Imports(as % of merchandise exports) of Mauritania?
Your answer should be very brief. -12.04. In the year 2006, what is the difference between the Imports(as % of merchandise exports) of World and Imports(as % of merchandise exports) of South Africa?
Ensure brevity in your answer.  -3.52. In the year 2006, what is the difference between the Imports(as % of merchandise exports) of Brunei Darussalam and Imports(as % of merchandise exports) of Mauritania?
Make the answer very short. -25.25. In the year 2006, what is the difference between the Imports(as % of merchandise exports) in Brunei Darussalam and Imports(as % of merchandise exports) in South Africa?
Provide a succinct answer. -16.73. In the year 2006, what is the difference between the Imports(as % of merchandise exports) in Mauritania and Imports(as % of merchandise exports) in South Africa?
Your answer should be compact. 8.52. In the year 2012, what is the difference between the Imports(as % of merchandise exports) of World and Imports(as % of merchandise exports) of Brunei Darussalam?
Ensure brevity in your answer.  8.99. In the year 2012, what is the difference between the Imports(as % of merchandise exports) in World and Imports(as % of merchandise exports) in Mauritania?
Make the answer very short. -7.94. In the year 2012, what is the difference between the Imports(as % of merchandise exports) in World and Imports(as % of merchandise exports) in South Africa?
Your response must be concise. -3.43. In the year 2012, what is the difference between the Imports(as % of merchandise exports) of Brunei Darussalam and Imports(as % of merchandise exports) of Mauritania?
Ensure brevity in your answer.  -16.93. In the year 2012, what is the difference between the Imports(as % of merchandise exports) of Brunei Darussalam and Imports(as % of merchandise exports) of South Africa?
Your response must be concise. -12.42. In the year 2012, what is the difference between the Imports(as % of merchandise exports) of Mauritania and Imports(as % of merchandise exports) of South Africa?
Your answer should be very brief. 4.51. In the year 2013, what is the difference between the Imports(as % of merchandise exports) of World and Imports(as % of merchandise exports) of Brunei Darussalam?
Provide a succinct answer. 10.41. In the year 2013, what is the difference between the Imports(as % of merchandise exports) in World and Imports(as % of merchandise exports) in Mauritania?
Offer a very short reply. -2.17. In the year 2013, what is the difference between the Imports(as % of merchandise exports) of World and Imports(as % of merchandise exports) of South Africa?
Your response must be concise. -3.67. In the year 2013, what is the difference between the Imports(as % of merchandise exports) in Brunei Darussalam and Imports(as % of merchandise exports) in Mauritania?
Ensure brevity in your answer.  -12.57. In the year 2013, what is the difference between the Imports(as % of merchandise exports) in Brunei Darussalam and Imports(as % of merchandise exports) in South Africa?
Make the answer very short. -14.08. In the year 2013, what is the difference between the Imports(as % of merchandise exports) of Mauritania and Imports(as % of merchandise exports) of South Africa?
Give a very brief answer. -1.5. What is the ratio of the Imports(as % of merchandise exports) of World in 2001 to that in 2002?
Provide a short and direct response. 1.04. What is the ratio of the Imports(as % of merchandise exports) of Brunei Darussalam in 2001 to that in 2002?
Your answer should be very brief. 1.11. What is the ratio of the Imports(as % of merchandise exports) in Mauritania in 2001 to that in 2002?
Keep it short and to the point. 1.08. What is the ratio of the Imports(as % of merchandise exports) of South Africa in 2001 to that in 2002?
Provide a short and direct response. 1.18. What is the ratio of the Imports(as % of merchandise exports) in World in 2001 to that in 2003?
Offer a terse response. 0.97. What is the ratio of the Imports(as % of merchandise exports) of Brunei Darussalam in 2001 to that in 2003?
Offer a very short reply. 0.61. What is the ratio of the Imports(as % of merchandise exports) in Mauritania in 2001 to that in 2003?
Your answer should be compact. 1.45. What is the ratio of the Imports(as % of merchandise exports) in South Africa in 2001 to that in 2003?
Offer a very short reply. 1.23. What is the ratio of the Imports(as % of merchandise exports) of World in 2001 to that in 2004?
Ensure brevity in your answer.  0.89. What is the ratio of the Imports(as % of merchandise exports) of Brunei Darussalam in 2001 to that in 2004?
Make the answer very short. 0.74. What is the ratio of the Imports(as % of merchandise exports) of Mauritania in 2001 to that in 2004?
Ensure brevity in your answer.  3.77. What is the ratio of the Imports(as % of merchandise exports) of South Africa in 2001 to that in 2004?
Your response must be concise. 1.02. What is the ratio of the Imports(as % of merchandise exports) of World in 2001 to that in 2006?
Ensure brevity in your answer.  0.68. What is the ratio of the Imports(as % of merchandise exports) in Brunei Darussalam in 2001 to that in 2006?
Offer a terse response. 0.39. What is the ratio of the Imports(as % of merchandise exports) of Mauritania in 2001 to that in 2006?
Provide a short and direct response. 0.89. What is the ratio of the Imports(as % of merchandise exports) of South Africa in 2001 to that in 2006?
Make the answer very short. 0.8. What is the ratio of the Imports(as % of merchandise exports) in World in 2001 to that in 2012?
Make the answer very short. 0.55. What is the ratio of the Imports(as % of merchandise exports) in Brunei Darussalam in 2001 to that in 2012?
Your response must be concise. 0.07. What is the ratio of the Imports(as % of merchandise exports) in Mauritania in 2001 to that in 2012?
Your answer should be compact. 0.9. What is the ratio of the Imports(as % of merchandise exports) of South Africa in 2001 to that in 2012?
Offer a very short reply. 0.67. What is the ratio of the Imports(as % of merchandise exports) in World in 2001 to that in 2013?
Your response must be concise. 0.57. What is the ratio of the Imports(as % of merchandise exports) in Brunei Darussalam in 2001 to that in 2013?
Provide a succinct answer. 0.09. What is the ratio of the Imports(as % of merchandise exports) in Mauritania in 2001 to that in 2013?
Keep it short and to the point. 1.19. What is the ratio of the Imports(as % of merchandise exports) in South Africa in 2001 to that in 2013?
Provide a short and direct response. 0.68. What is the ratio of the Imports(as % of merchandise exports) of World in 2002 to that in 2003?
Keep it short and to the point. 0.93. What is the ratio of the Imports(as % of merchandise exports) of Brunei Darussalam in 2002 to that in 2003?
Offer a terse response. 0.55. What is the ratio of the Imports(as % of merchandise exports) in Mauritania in 2002 to that in 2003?
Your answer should be very brief. 1.34. What is the ratio of the Imports(as % of merchandise exports) in South Africa in 2002 to that in 2003?
Offer a terse response. 1.04. What is the ratio of the Imports(as % of merchandise exports) of World in 2002 to that in 2004?
Make the answer very short. 0.85. What is the ratio of the Imports(as % of merchandise exports) in Brunei Darussalam in 2002 to that in 2004?
Give a very brief answer. 0.67. What is the ratio of the Imports(as % of merchandise exports) in Mauritania in 2002 to that in 2004?
Give a very brief answer. 3.48. What is the ratio of the Imports(as % of merchandise exports) in South Africa in 2002 to that in 2004?
Your response must be concise. 0.86. What is the ratio of the Imports(as % of merchandise exports) of World in 2002 to that in 2006?
Offer a terse response. 0.66. What is the ratio of the Imports(as % of merchandise exports) in Brunei Darussalam in 2002 to that in 2006?
Provide a short and direct response. 0.35. What is the ratio of the Imports(as % of merchandise exports) of Mauritania in 2002 to that in 2006?
Make the answer very short. 0.82. What is the ratio of the Imports(as % of merchandise exports) in South Africa in 2002 to that in 2006?
Your answer should be compact. 0.68. What is the ratio of the Imports(as % of merchandise exports) in World in 2002 to that in 2012?
Provide a short and direct response. 0.52. What is the ratio of the Imports(as % of merchandise exports) in Brunei Darussalam in 2002 to that in 2012?
Your answer should be compact. 0.06. What is the ratio of the Imports(as % of merchandise exports) of Mauritania in 2002 to that in 2012?
Your response must be concise. 0.83. What is the ratio of the Imports(as % of merchandise exports) in South Africa in 2002 to that in 2012?
Give a very brief answer. 0.57. What is the ratio of the Imports(as % of merchandise exports) in World in 2002 to that in 2013?
Offer a terse response. 0.54. What is the ratio of the Imports(as % of merchandise exports) in Brunei Darussalam in 2002 to that in 2013?
Your answer should be very brief. 0.08. What is the ratio of the Imports(as % of merchandise exports) of Mauritania in 2002 to that in 2013?
Your response must be concise. 1.1. What is the ratio of the Imports(as % of merchandise exports) of South Africa in 2002 to that in 2013?
Provide a succinct answer. 0.58. What is the ratio of the Imports(as % of merchandise exports) in World in 2003 to that in 2004?
Provide a succinct answer. 0.92. What is the ratio of the Imports(as % of merchandise exports) in Brunei Darussalam in 2003 to that in 2004?
Offer a very short reply. 1.22. What is the ratio of the Imports(as % of merchandise exports) of Mauritania in 2003 to that in 2004?
Give a very brief answer. 2.6. What is the ratio of the Imports(as % of merchandise exports) of South Africa in 2003 to that in 2004?
Your answer should be very brief. 0.83. What is the ratio of the Imports(as % of merchandise exports) in World in 2003 to that in 2006?
Your response must be concise. 0.71. What is the ratio of the Imports(as % of merchandise exports) in Brunei Darussalam in 2003 to that in 2006?
Offer a very short reply. 0.63. What is the ratio of the Imports(as % of merchandise exports) of Mauritania in 2003 to that in 2006?
Your response must be concise. 0.61. What is the ratio of the Imports(as % of merchandise exports) in South Africa in 2003 to that in 2006?
Ensure brevity in your answer.  0.65. What is the ratio of the Imports(as % of merchandise exports) in World in 2003 to that in 2012?
Make the answer very short. 0.56. What is the ratio of the Imports(as % of merchandise exports) in Brunei Darussalam in 2003 to that in 2012?
Provide a succinct answer. 0.11. What is the ratio of the Imports(as % of merchandise exports) of Mauritania in 2003 to that in 2012?
Keep it short and to the point. 0.62. What is the ratio of the Imports(as % of merchandise exports) in South Africa in 2003 to that in 2012?
Give a very brief answer. 0.54. What is the ratio of the Imports(as % of merchandise exports) of World in 2003 to that in 2013?
Offer a very short reply. 0.59. What is the ratio of the Imports(as % of merchandise exports) of Brunei Darussalam in 2003 to that in 2013?
Ensure brevity in your answer.  0.14. What is the ratio of the Imports(as % of merchandise exports) of Mauritania in 2003 to that in 2013?
Ensure brevity in your answer.  0.82. What is the ratio of the Imports(as % of merchandise exports) in South Africa in 2003 to that in 2013?
Make the answer very short. 0.55. What is the ratio of the Imports(as % of merchandise exports) in World in 2004 to that in 2006?
Provide a short and direct response. 0.77. What is the ratio of the Imports(as % of merchandise exports) in Brunei Darussalam in 2004 to that in 2006?
Your answer should be very brief. 0.52. What is the ratio of the Imports(as % of merchandise exports) in Mauritania in 2004 to that in 2006?
Your answer should be very brief. 0.24. What is the ratio of the Imports(as % of merchandise exports) of South Africa in 2004 to that in 2006?
Make the answer very short. 0.79. What is the ratio of the Imports(as % of merchandise exports) in World in 2004 to that in 2012?
Make the answer very short. 0.62. What is the ratio of the Imports(as % of merchandise exports) in Brunei Darussalam in 2004 to that in 2012?
Provide a succinct answer. 0.09. What is the ratio of the Imports(as % of merchandise exports) in Mauritania in 2004 to that in 2012?
Offer a terse response. 0.24. What is the ratio of the Imports(as % of merchandise exports) of South Africa in 2004 to that in 2012?
Offer a very short reply. 0.66. What is the ratio of the Imports(as % of merchandise exports) of World in 2004 to that in 2013?
Ensure brevity in your answer.  0.64. What is the ratio of the Imports(as % of merchandise exports) in Brunei Darussalam in 2004 to that in 2013?
Offer a very short reply. 0.11. What is the ratio of the Imports(as % of merchandise exports) in Mauritania in 2004 to that in 2013?
Offer a very short reply. 0.32. What is the ratio of the Imports(as % of merchandise exports) of South Africa in 2004 to that in 2013?
Your response must be concise. 0.67. What is the ratio of the Imports(as % of merchandise exports) of World in 2006 to that in 2012?
Give a very brief answer. 0.8. What is the ratio of the Imports(as % of merchandise exports) of Brunei Darussalam in 2006 to that in 2012?
Your answer should be compact. 0.17. What is the ratio of the Imports(as % of merchandise exports) in Mauritania in 2006 to that in 2012?
Give a very brief answer. 1.01. What is the ratio of the Imports(as % of merchandise exports) of South Africa in 2006 to that in 2012?
Your response must be concise. 0.83. What is the ratio of the Imports(as % of merchandise exports) in World in 2006 to that in 2013?
Your response must be concise. 0.83. What is the ratio of the Imports(as % of merchandise exports) of Brunei Darussalam in 2006 to that in 2013?
Ensure brevity in your answer.  0.22. What is the ratio of the Imports(as % of merchandise exports) in Mauritania in 2006 to that in 2013?
Provide a succinct answer. 1.34. What is the ratio of the Imports(as % of merchandise exports) in South Africa in 2006 to that in 2013?
Give a very brief answer. 0.85. What is the ratio of the Imports(as % of merchandise exports) in World in 2012 to that in 2013?
Ensure brevity in your answer.  1.04. What is the ratio of the Imports(as % of merchandise exports) of Brunei Darussalam in 2012 to that in 2013?
Offer a terse response. 1.28. What is the ratio of the Imports(as % of merchandise exports) of Mauritania in 2012 to that in 2013?
Ensure brevity in your answer.  1.32. What is the ratio of the Imports(as % of merchandise exports) in South Africa in 2012 to that in 2013?
Offer a terse response. 1.02. What is the difference between the highest and the second highest Imports(as % of merchandise exports) in World?
Offer a very short reply. 0.71. What is the difference between the highest and the second highest Imports(as % of merchandise exports) of Brunei Darussalam?
Offer a terse response. 2.13. What is the difference between the highest and the second highest Imports(as % of merchandise exports) of Mauritania?
Ensure brevity in your answer.  0.33. What is the difference between the highest and the second highest Imports(as % of merchandise exports) of South Africa?
Provide a succinct answer. 0.48. What is the difference between the highest and the lowest Imports(as % of merchandise exports) in World?
Provide a succinct answer. 8.88. What is the difference between the highest and the lowest Imports(as % of merchandise exports) in Brunei Darussalam?
Your answer should be very brief. 9.07. What is the difference between the highest and the lowest Imports(as % of merchandise exports) in Mauritania?
Offer a terse response. 20.55. What is the difference between the highest and the lowest Imports(as % of merchandise exports) of South Africa?
Give a very brief answer. 10.09. 